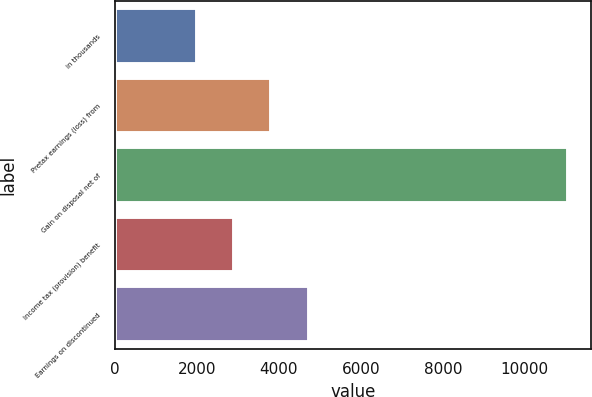Convert chart to OTSL. <chart><loc_0><loc_0><loc_500><loc_500><bar_chart><fcel>in thousands<fcel>Pretax earnings (loss) from<fcel>Gain on disposal net of<fcel>Income tax (provision) benefit<fcel>Earnings on discontinued<nl><fcel>2011<fcel>3820<fcel>11056<fcel>2915.5<fcel>4724.5<nl></chart> 